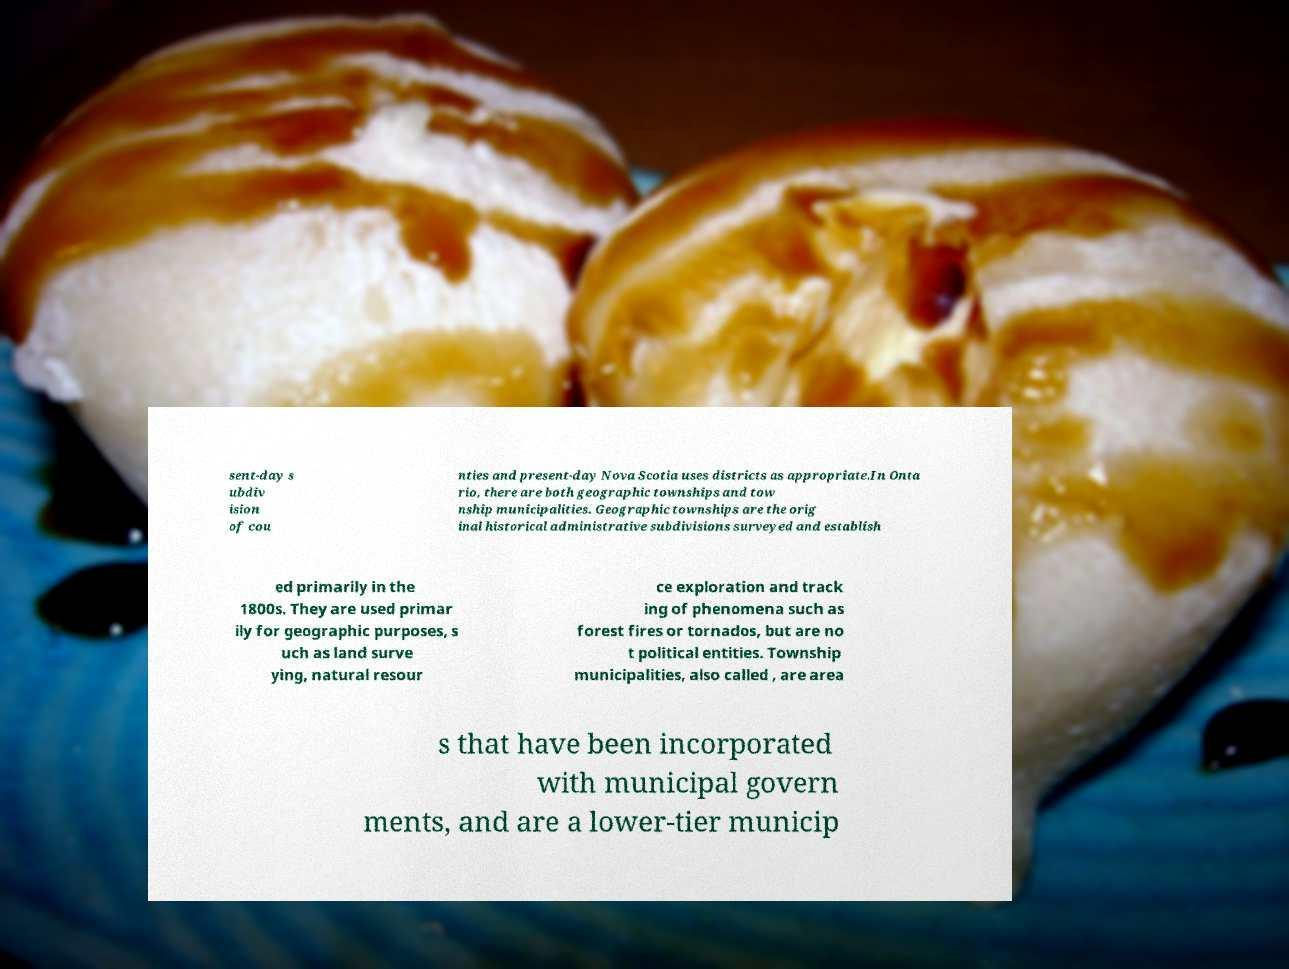Can you read and provide the text displayed in the image?This photo seems to have some interesting text. Can you extract and type it out for me? sent-day s ubdiv ision of cou nties and present-day Nova Scotia uses districts as appropriate.In Onta rio, there are both geographic townships and tow nship municipalities. Geographic townships are the orig inal historical administrative subdivisions surveyed and establish ed primarily in the 1800s. They are used primar ily for geographic purposes, s uch as land surve ying, natural resour ce exploration and track ing of phenomena such as forest fires or tornados, but are no t political entities. Township municipalities, also called , are area s that have been incorporated with municipal govern ments, and are a lower-tier municip 